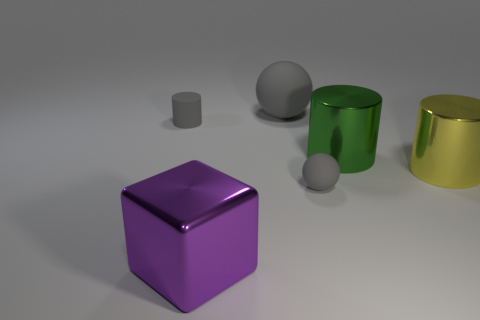What is the material of the other large thing that is the same shape as the big yellow shiny object?
Your answer should be very brief. Metal. How many objects are big metallic objects in front of the large yellow shiny thing or big gray matte spheres?
Make the answer very short. 2. What shape is the green thing that is the same material as the yellow object?
Offer a very short reply. Cylinder. What number of gray objects are the same shape as the large green object?
Your response must be concise. 1. What material is the green cylinder?
Offer a terse response. Metal. There is a small cylinder; does it have the same color as the tiny matte thing on the right side of the metallic block?
Make the answer very short. Yes. How many cubes are big green shiny things or yellow things?
Give a very brief answer. 0. The shiny object to the left of the tiny rubber sphere is what color?
Your answer should be very brief. Purple. There is a large matte thing that is the same color as the matte cylinder; what shape is it?
Your response must be concise. Sphere. What number of other rubber cylinders are the same size as the matte cylinder?
Your response must be concise. 0. 